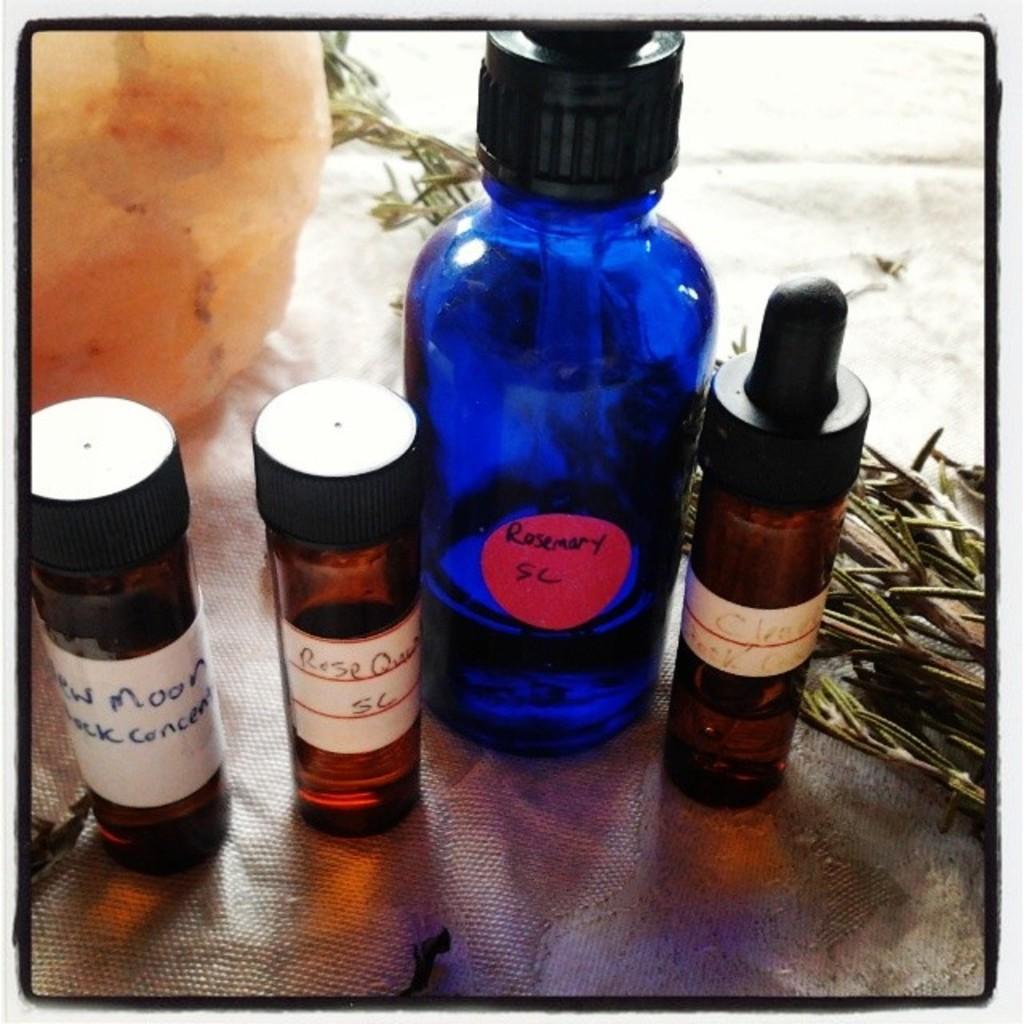What is in the jar?
Make the answer very short. Rosemary. Which flower is mentioned on the two middle bottles?
Provide a succinct answer. Rose. 